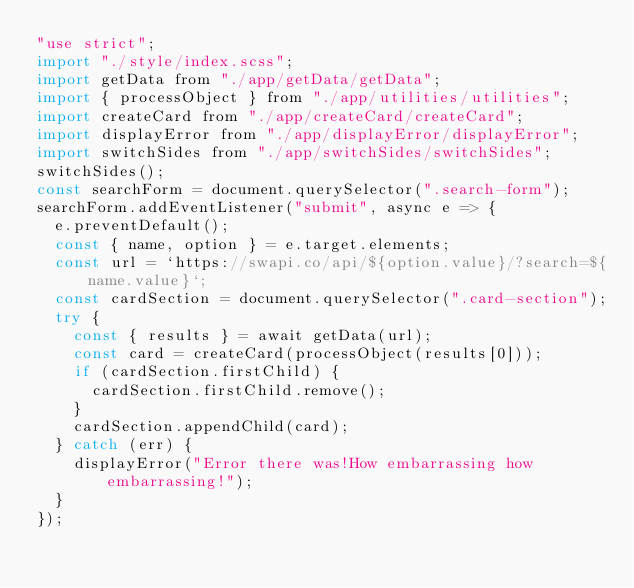<code> <loc_0><loc_0><loc_500><loc_500><_JavaScript_>"use strict";
import "./style/index.scss";
import getData from "./app/getData/getData";
import { processObject } from "./app/utilities/utilities";
import createCard from "./app/createCard/createCard";
import displayError from "./app/displayError/displayError";
import switchSides from "./app/switchSides/switchSides";
switchSides();
const searchForm = document.querySelector(".search-form");
searchForm.addEventListener("submit", async e => {
  e.preventDefault();
  const { name, option } = e.target.elements;
  const url = `https://swapi.co/api/${option.value}/?search=${name.value}`;
  const cardSection = document.querySelector(".card-section");
  try {
    const { results } = await getData(url);
    const card = createCard(processObject(results[0]));
    if (cardSection.firstChild) {
      cardSection.firstChild.remove();
    }
    cardSection.appendChild(card);
  } catch (err) {
    displayError("Error there was!How embarrassing how embarrassing!");
  }
});
</code> 